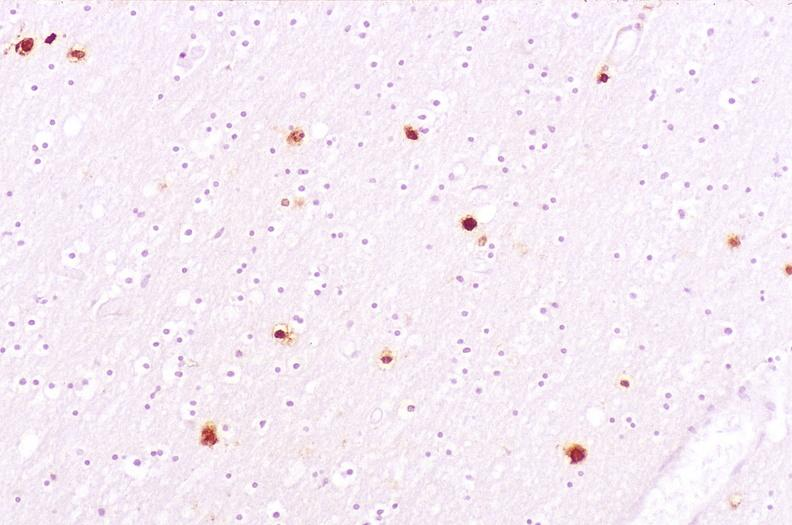does this image show brain, herpes simplex encephalitis?
Answer the question using a single word or phrase. Yes 